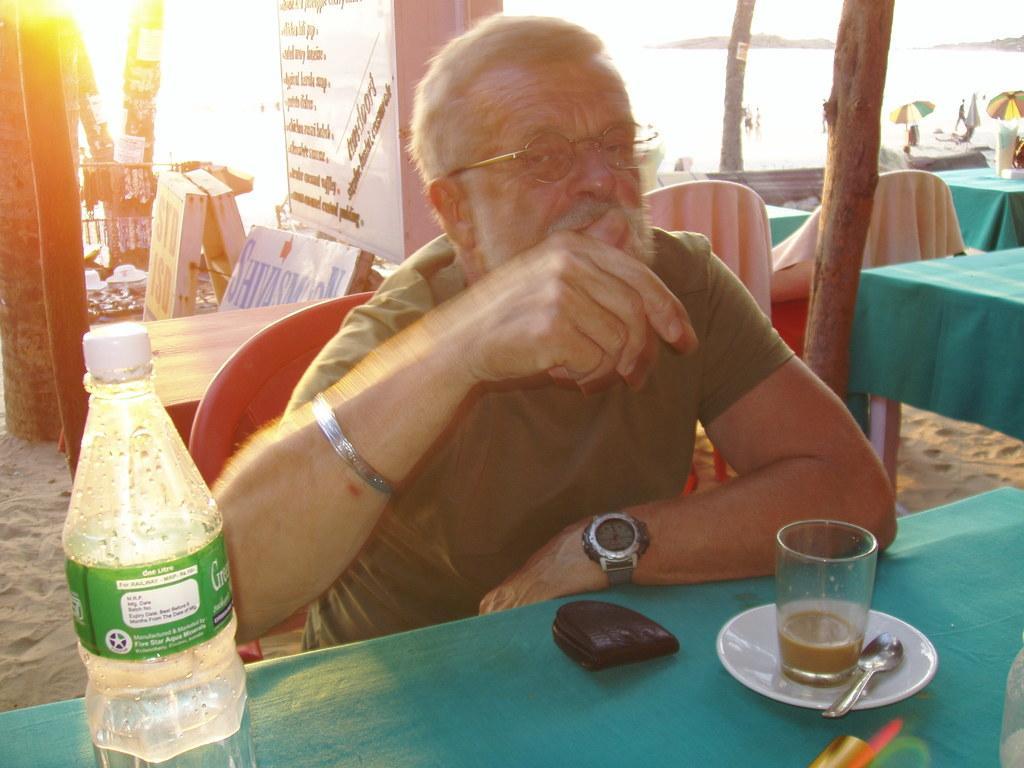Describe this image in one or two sentences. In this image I see a man and he is sitting on the chair and there is table in front. In the background I can see few boards, few chairs and tables. 